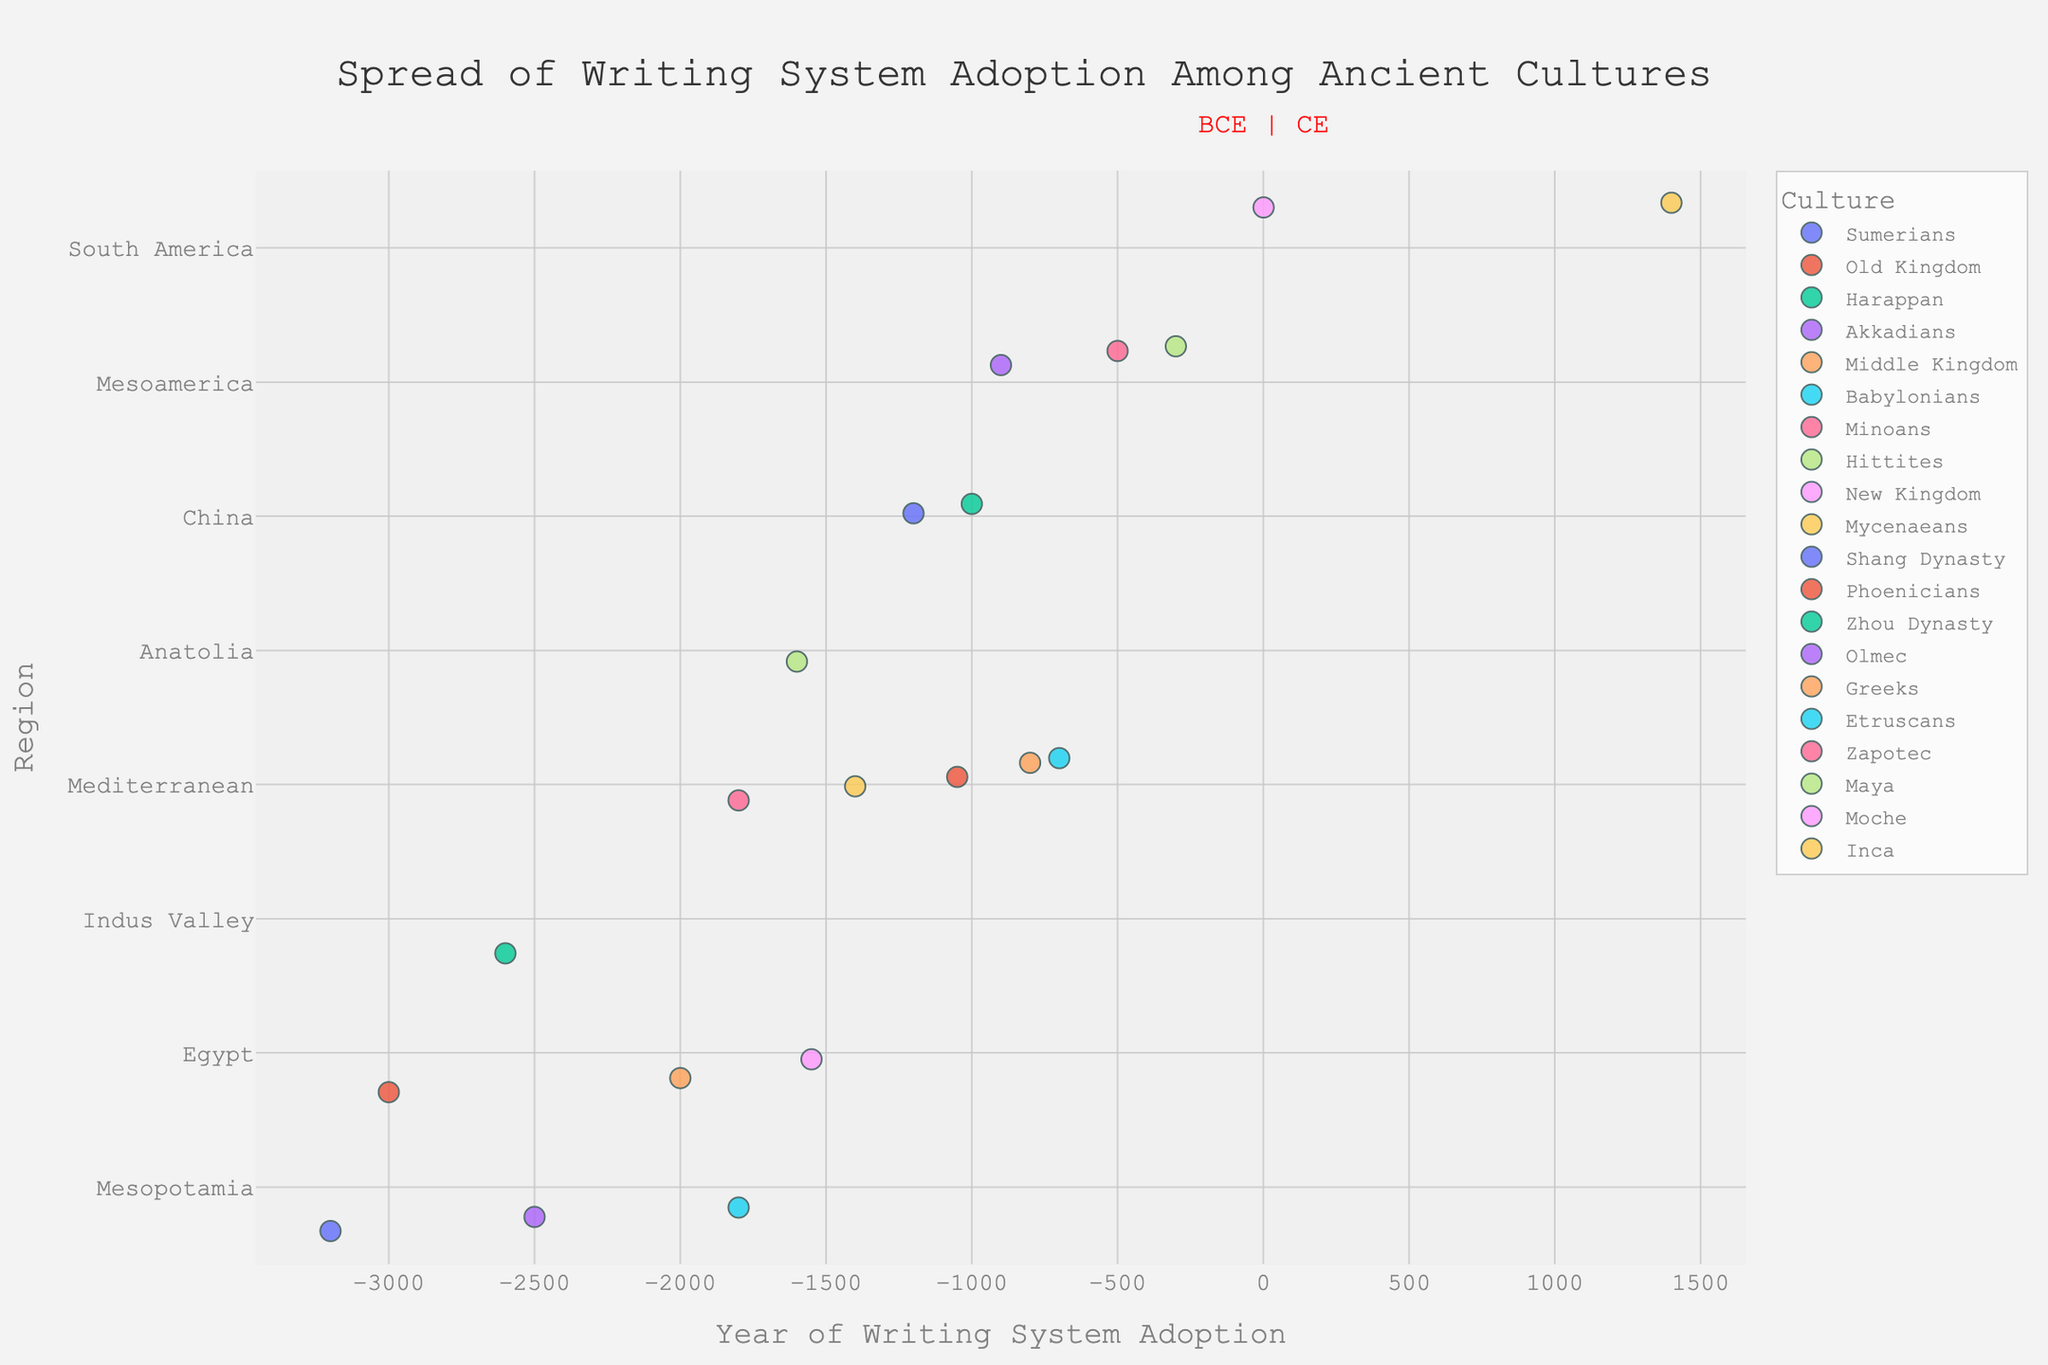How many ancient cultures from Mesoamerica are represented in the plot? Count the number of distinct data points (markers) associated with the Mesoamerica region.
Answer: 3 What region shows the earliest adoption of a writing system according to the plot, and which culture does it belong to? Identify the leftmost point on the x-axis and check which region and culture it is associated with.
Answer: Mesopotamia, Sumerians What's the difference in years between the adoption of writing systems by the Harappan culture and the Shang Dynasty? Find the adoption years for both the Harappan (-2600) and the Shang Dynasty (-1200) and subtract the former from the latter.
Answer: -1400 years Which region has the highest number of cultures adopting writing systems relatively late (after 0 CE)? Examine the data points on the right side of the x-axis (after 0 CE) and see which region is represented the most.
Answer: South America Compare the general time frame of writing system adoption in Mesopotamia and Egypt. Which region shows a larger spread in years? Look at the range of years for Mesopotamia (-3200 to -1800) and Egypt (-3000 to -1550). Calculate the range for both and compare.
Answer: Mesopotamia What's the median adoption year for writing systems among cultures in the Mediterranean region? List the adoption years for Mediterranean cultures (-1800, -1400, -1050, -800, -700) and find the middle value.
Answer: -1050 How are the cultures in the Mediterranean region distributed in the adoption of writing systems relative to the cultures in Anatolia? Check the relative positions of the data points for Mediterranean and Anatolia regions along the x-axis. Compare their distributions.
Answer: Mediterranean cultures are generally later What cultures adopted writing systems around the year -1500? Look for data points around the year -1500 and note the associated cultures.
Answer: New Kingdom, Mycenaeans What's the average year of writing system adoption for the cultures in Mesopotamia? Sum the adoption years (-3200, -2500, -1800) and divide by the number of cultures (3).
Answer: -2500 Which region has the culture with the latest adoption of a writing system, and what year is it? Identify the rightmost point on the x-axis and check which region and culture it is associated with.
Answer: South America, Inca, 1400 